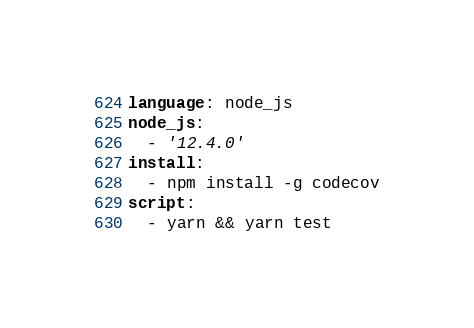Convert code to text. <code><loc_0><loc_0><loc_500><loc_500><_YAML_>language: node_js
node_js:
  - '12.4.0'
install:
  - npm install -g codecov
script:
  - yarn && yarn test
</code> 